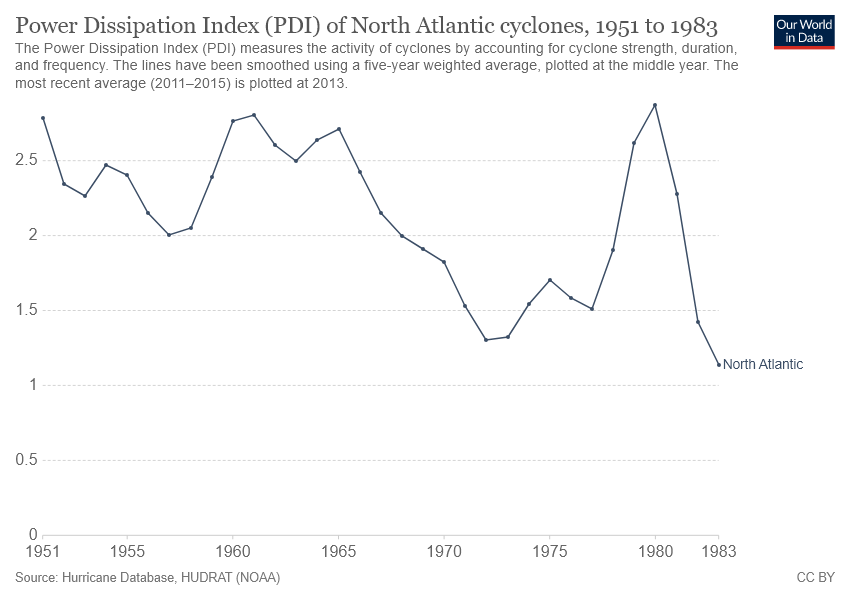Identify some key points in this picture. In 1977, the PDI (Power Dissipation Index) of a North Atlantic cyclone was 1.5, indicating a strong storm. The rate of North Atlantic in the year 1951 was greater than the rate in 1983. 